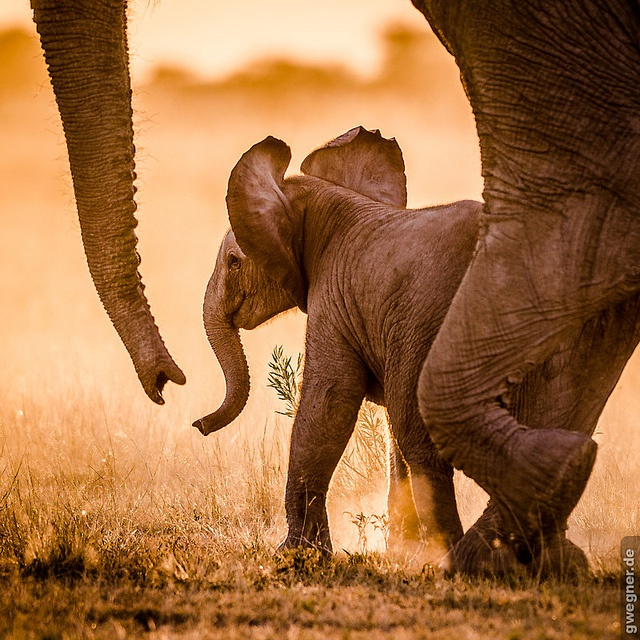Describe the objects in this image and their specific colors. I can see elephant in tan, maroon, black, and brown tones and elephant in tan, maroon, brown, and black tones in this image. 